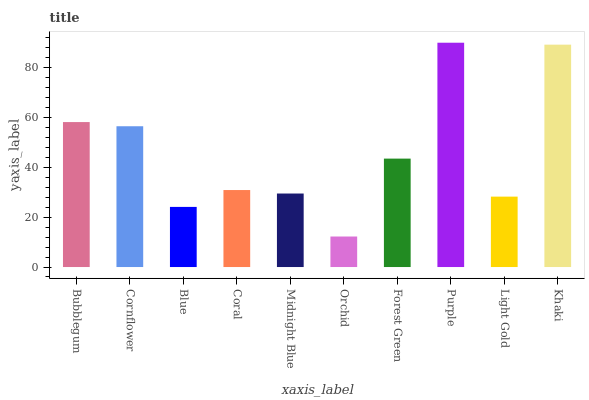Is Orchid the minimum?
Answer yes or no. Yes. Is Purple the maximum?
Answer yes or no. Yes. Is Cornflower the minimum?
Answer yes or no. No. Is Cornflower the maximum?
Answer yes or no. No. Is Bubblegum greater than Cornflower?
Answer yes or no. Yes. Is Cornflower less than Bubblegum?
Answer yes or no. Yes. Is Cornflower greater than Bubblegum?
Answer yes or no. No. Is Bubblegum less than Cornflower?
Answer yes or no. No. Is Forest Green the high median?
Answer yes or no. Yes. Is Coral the low median?
Answer yes or no. Yes. Is Light Gold the high median?
Answer yes or no. No. Is Khaki the low median?
Answer yes or no. No. 